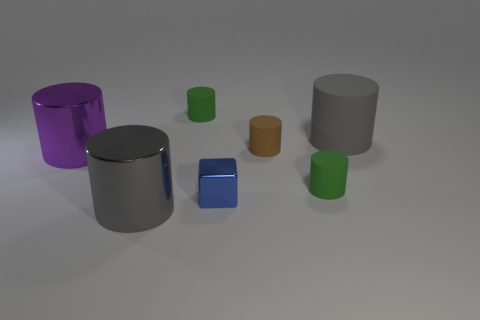Is the number of gray matte cylinders in front of the gray shiny thing greater than the number of small brown rubber cylinders?
Your answer should be compact. No. Is there any other thing that has the same material as the purple cylinder?
Keep it short and to the point. Yes. What is the shape of the metallic thing that is the same color as the large rubber cylinder?
Ensure brevity in your answer.  Cylinder. What number of cubes are gray shiny things or shiny objects?
Ensure brevity in your answer.  1. What is the color of the large thing on the right side of the large gray thing that is left of the large gray rubber cylinder?
Offer a very short reply. Gray. Does the cube have the same color as the tiny rubber thing that is in front of the tiny brown object?
Your answer should be very brief. No. What size is the gray object that is made of the same material as the brown object?
Make the answer very short. Large. What size is the thing that is the same color as the large matte cylinder?
Your answer should be compact. Large. Is the color of the large matte cylinder the same as the metal cube?
Your response must be concise. No. There is a small green matte cylinder that is left of the matte thing in front of the large purple thing; is there a green thing to the left of it?
Make the answer very short. No. 